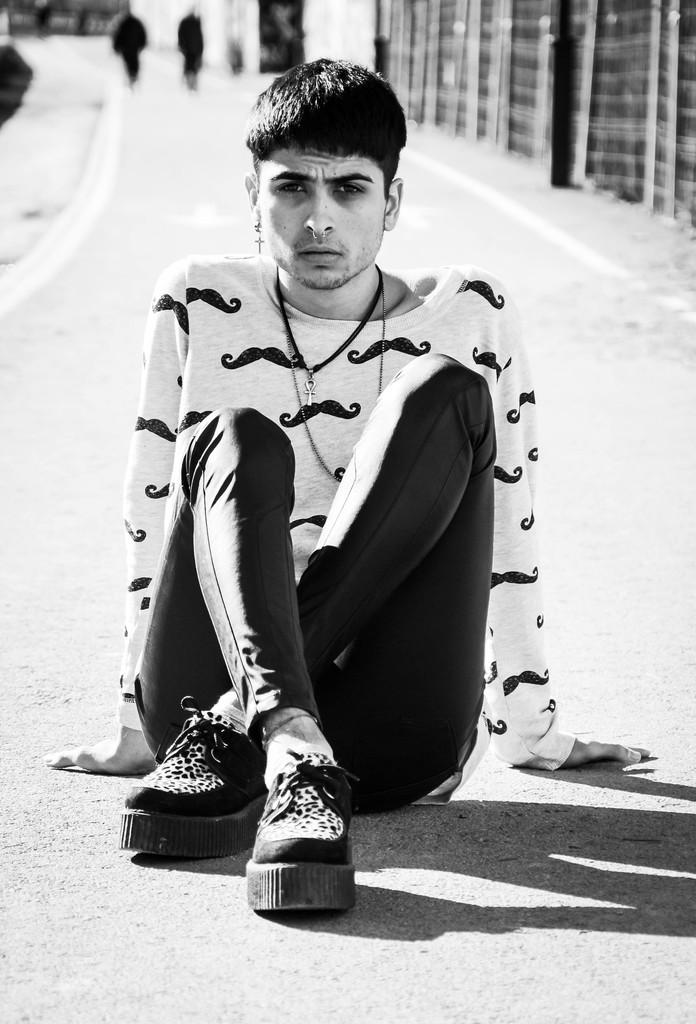Who is the main subject in the image? There is a boy in the image. What is the boy doing in the image? The boy is sitting on the road. Where is the boy located in the image? The boy is in the center of the image. Are there any other people in the image? Yes, there are other people in the image. What else can be seen in the image besides people? There are buildings in the image. Where are the buildings located in the image? The buildings are at the top side of the image. What type of string is the boy using to play with the trucks in the image? There are no trucks or string present in the image. What color is the skirt the boy is wearing in the image? The boy is not wearing a skirt in the image; he is wearing regular clothing. 